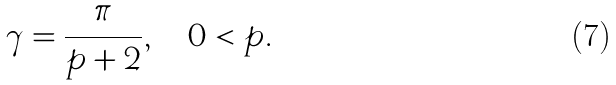<formula> <loc_0><loc_0><loc_500><loc_500>\gamma = \frac { \pi } { p + 2 } , \quad 0 < p .</formula> 